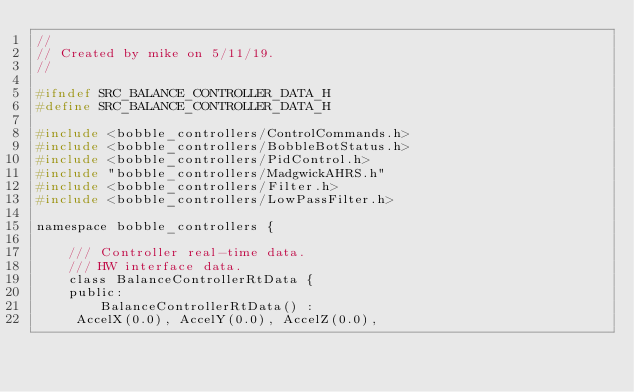<code> <loc_0><loc_0><loc_500><loc_500><_C_>//
// Created by mike on 5/11/19.
//

#ifndef SRC_BALANCE_CONTROLLER_DATA_H
#define SRC_BALANCE_CONTROLLER_DATA_H

#include <bobble_controllers/ControlCommands.h>
#include <bobble_controllers/BobbleBotStatus.h>
#include <bobble_controllers/PidControl.h>
#include "bobble_controllers/MadgwickAHRS.h"
#include <bobble_controllers/Filter.h>
#include <bobble_controllers/LowPassFilter.h>

namespace bobble_controllers {

    /// Controller real-time data.
    /// HW interface data.
    class BalanceControllerRtData {
    public:
        BalanceControllerRtData() :
	 AccelX(0.0), AccelY(0.0), AccelZ(0.0),</code> 